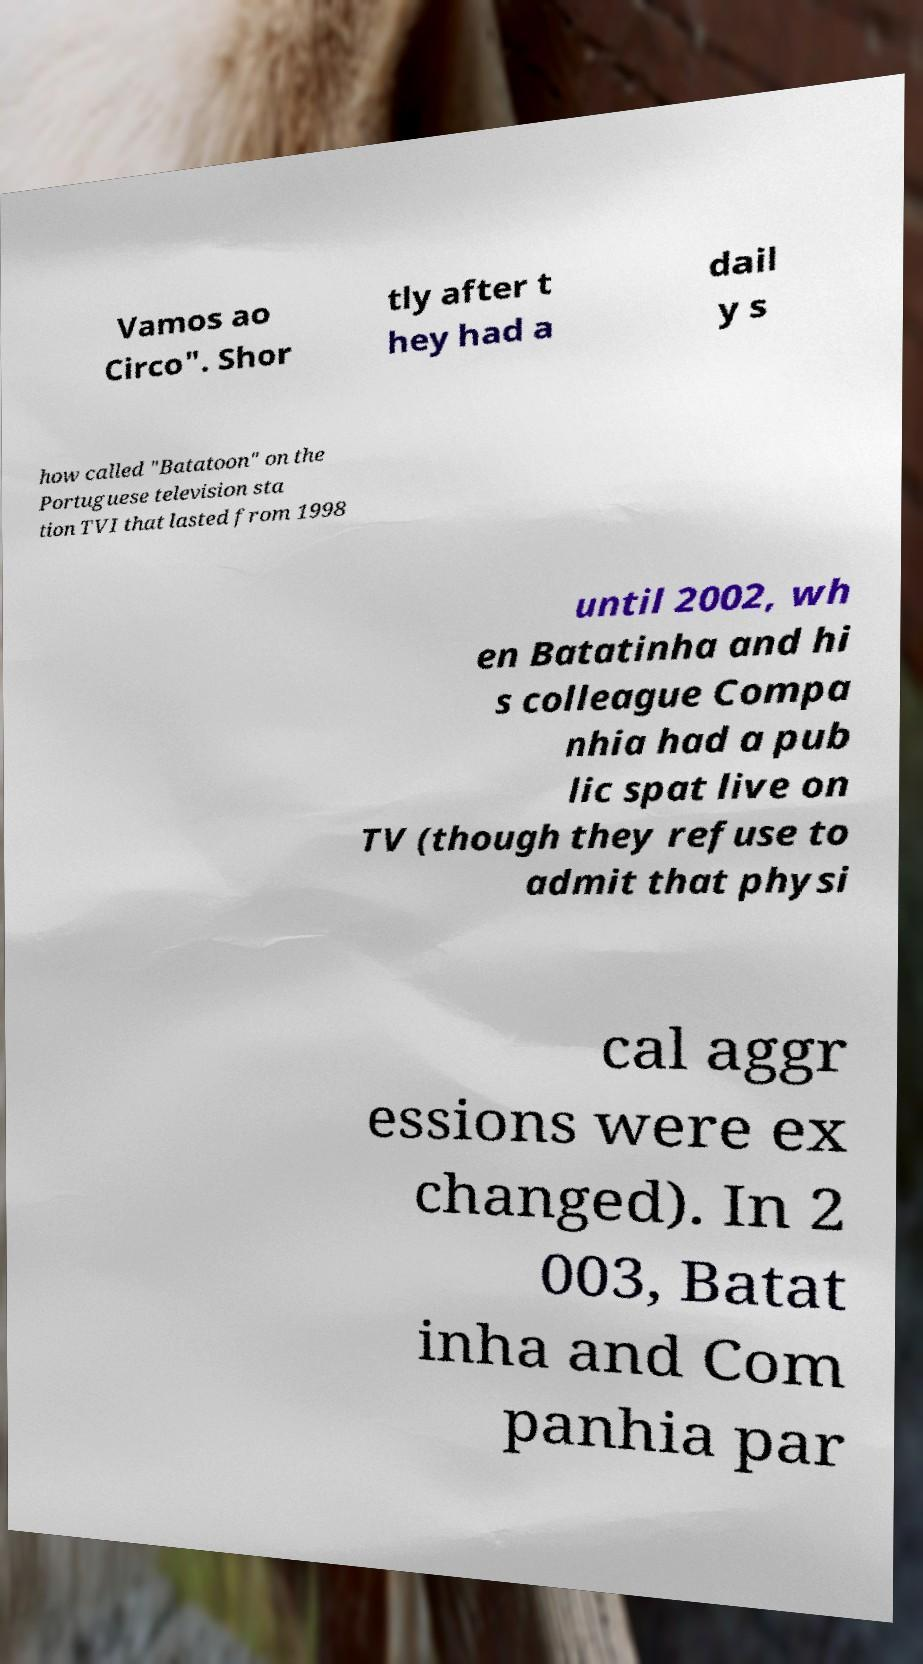Please read and relay the text visible in this image. What does it say? Vamos ao Circo". Shor tly after t hey had a dail y s how called "Batatoon" on the Portuguese television sta tion TVI that lasted from 1998 until 2002, wh en Batatinha and hi s colleague Compa nhia had a pub lic spat live on TV (though they refuse to admit that physi cal aggr essions were ex changed). In 2 003, Batat inha and Com panhia par 